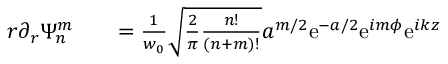Convert formula to latex. <formula><loc_0><loc_0><loc_500><loc_500>\begin{array} { r l r } { r \partial _ { r } \Psi _ { n } ^ { m } } & { = \frac { 1 } { w _ { 0 } } \sqrt { \frac { 2 } { \pi } \frac { n ! } { ( n + m ) ! } } a ^ { m / 2 } e ^ { - a / 2 } e ^ { i m \phi } e ^ { i k z } } \end{array}</formula> 